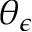Convert formula to latex. <formula><loc_0><loc_0><loc_500><loc_500>\theta _ { \epsilon }</formula> 